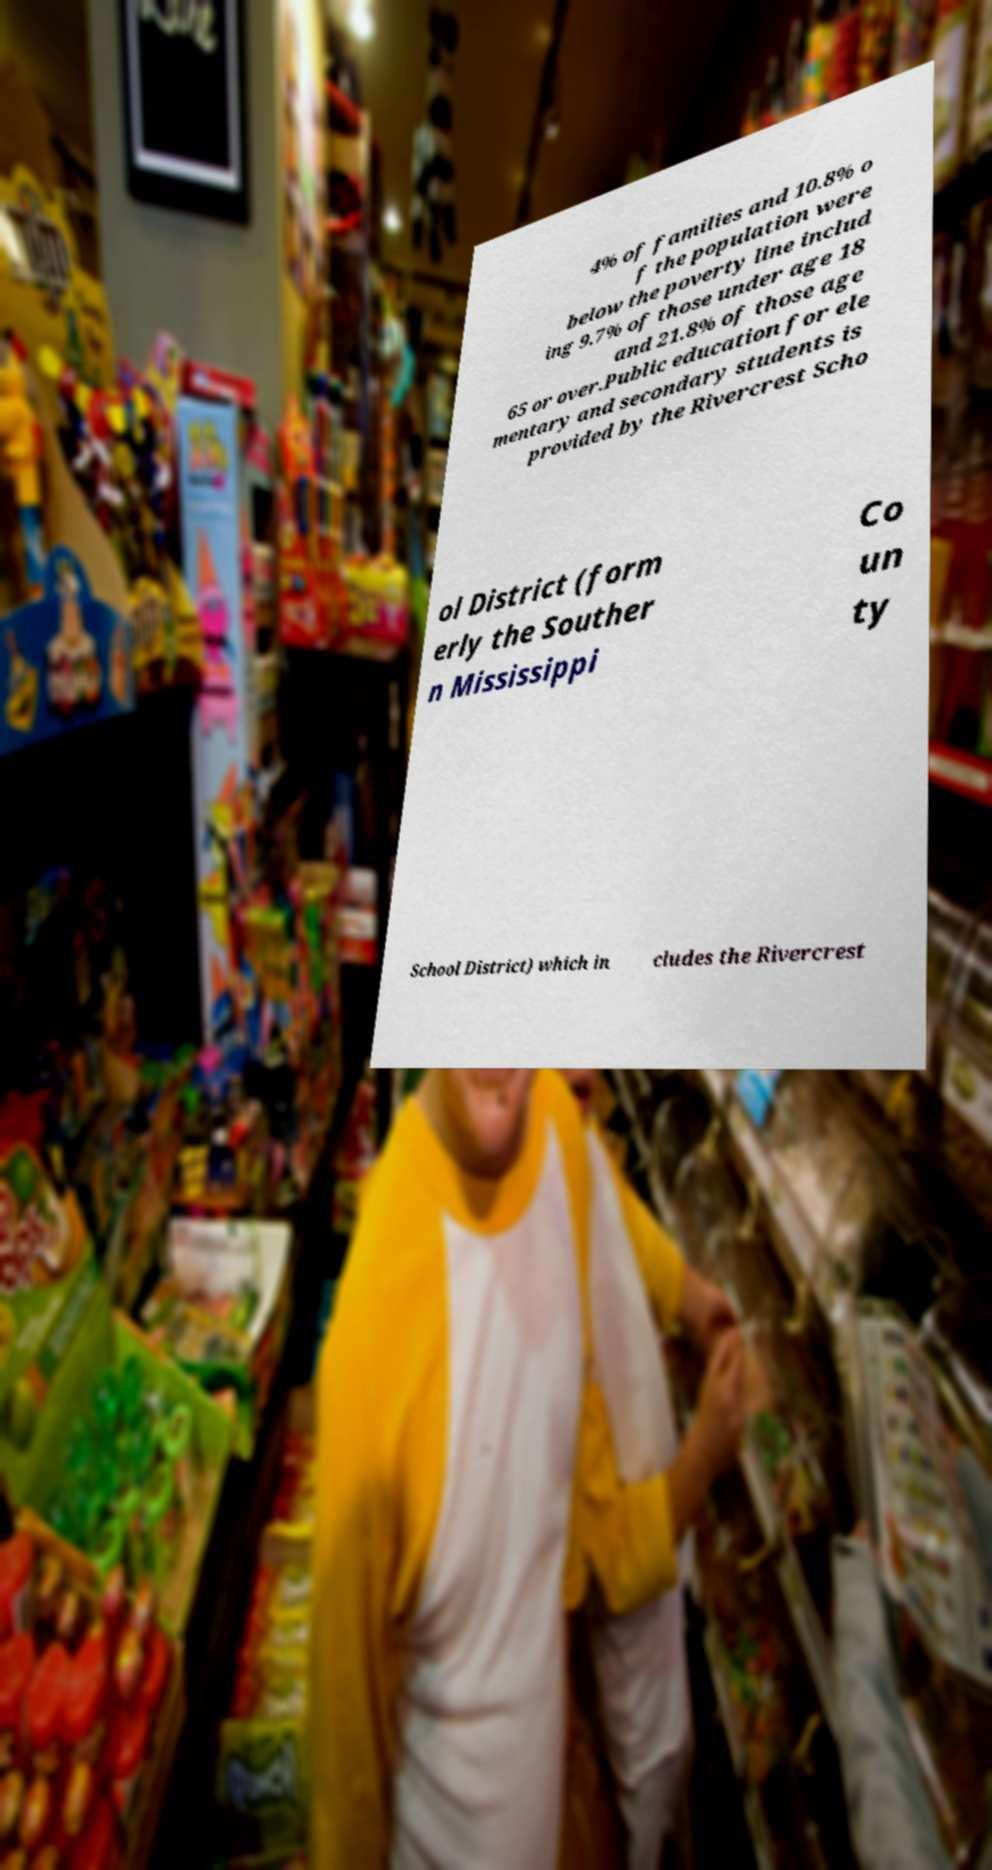Could you assist in decoding the text presented in this image and type it out clearly? 4% of families and 10.8% o f the population were below the poverty line includ ing 9.7% of those under age 18 and 21.8% of those age 65 or over.Public education for ele mentary and secondary students is provided by the Rivercrest Scho ol District (form erly the Souther n Mississippi Co un ty School District) which in cludes the Rivercrest 